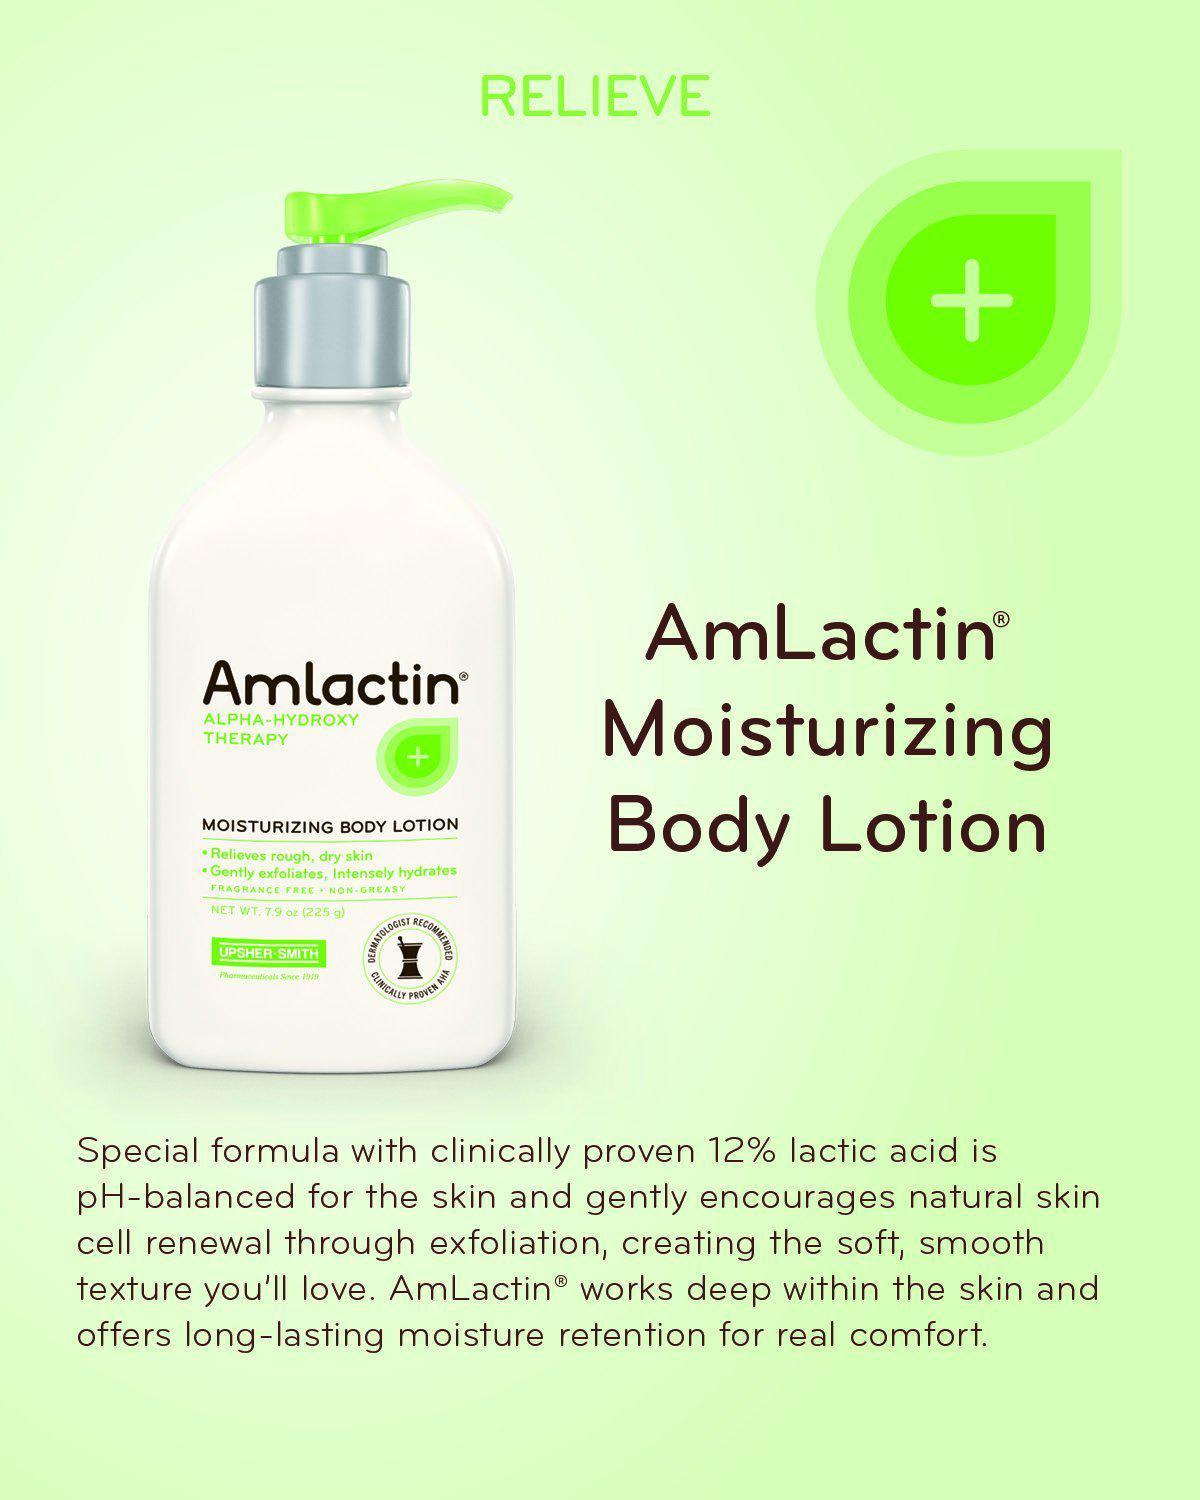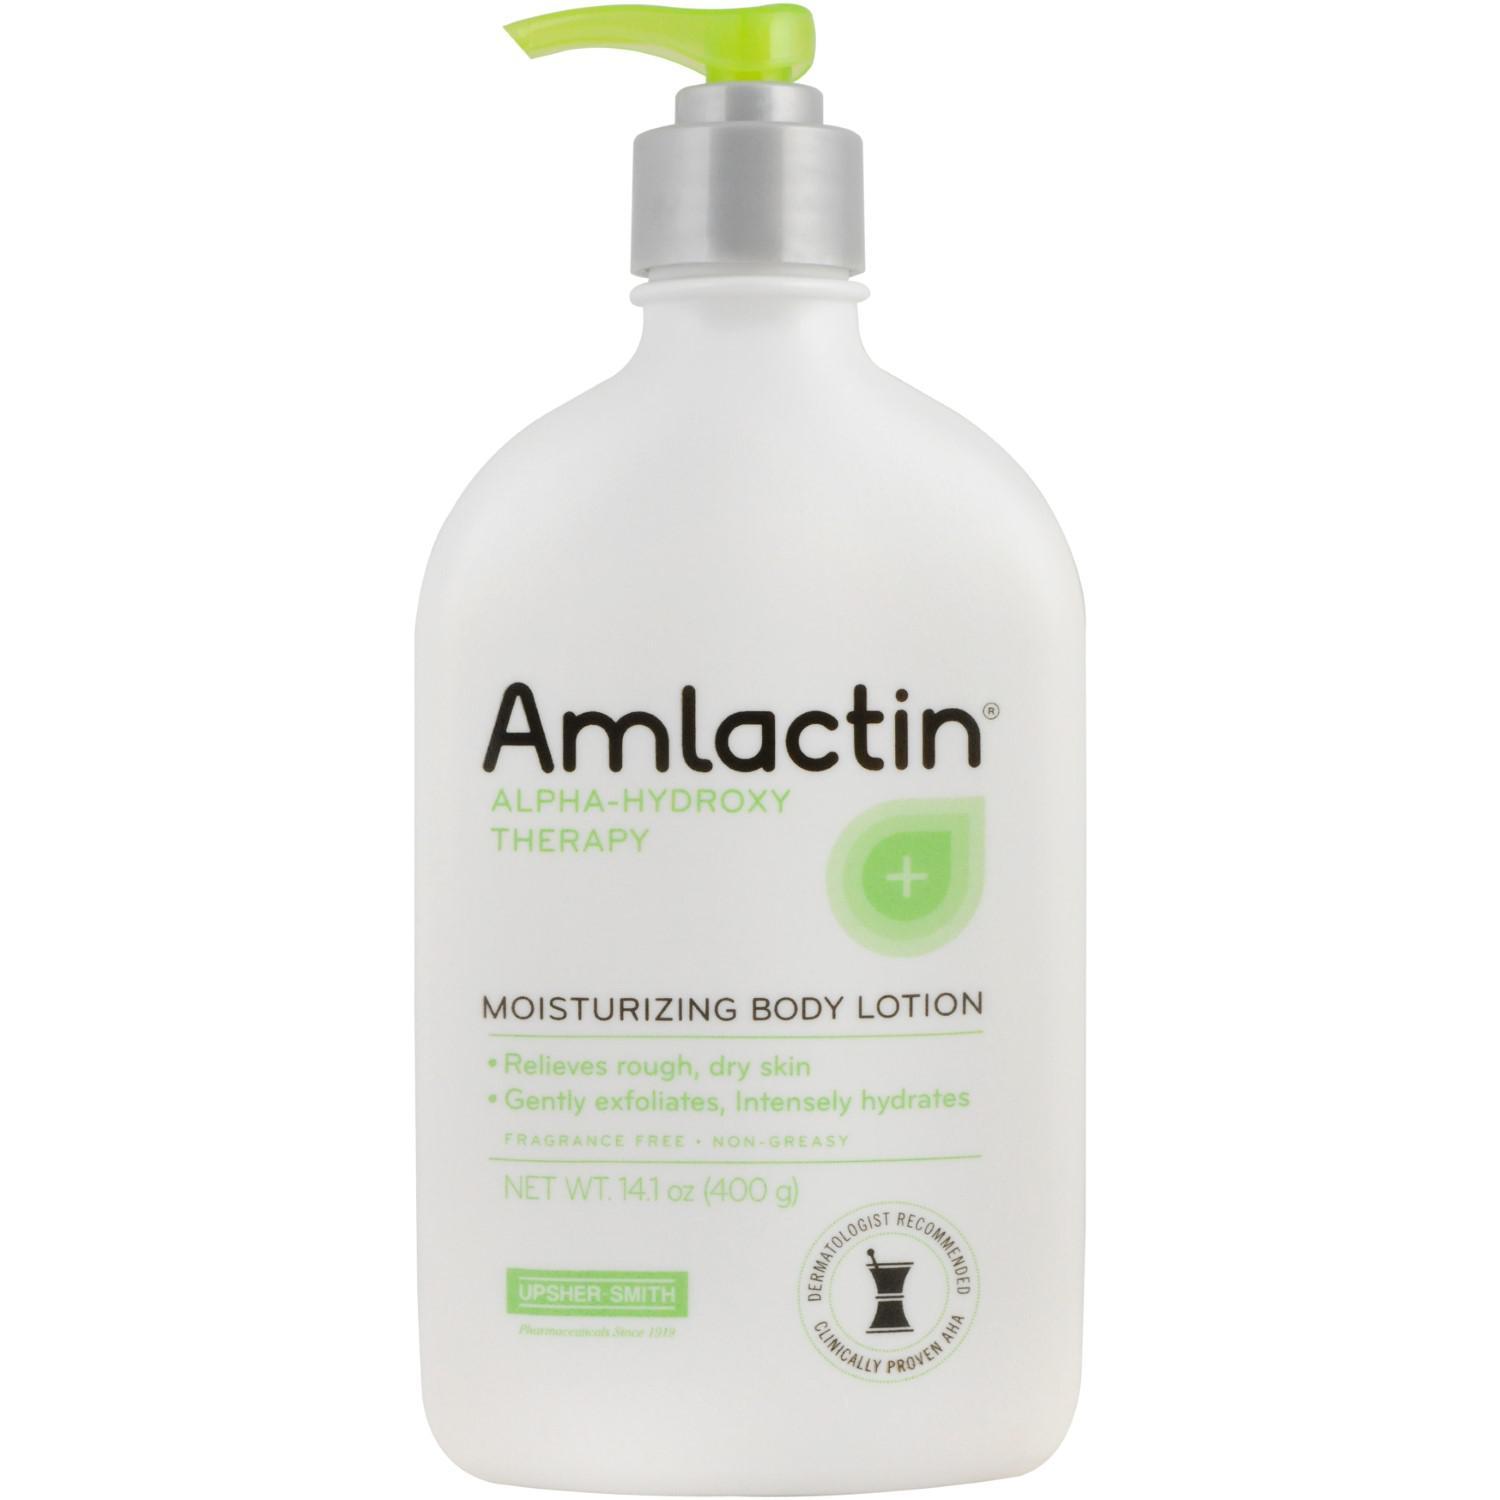The first image is the image on the left, the second image is the image on the right. Analyze the images presented: Is the assertion "At least one image contains no more than one lotion product outside of its box." valid? Answer yes or no. Yes. The first image is the image on the left, the second image is the image on the right. For the images displayed, is the sentence "In each image, at least five different personal care products are arranged in a row so that all labels are showing." factually correct? Answer yes or no. No. 